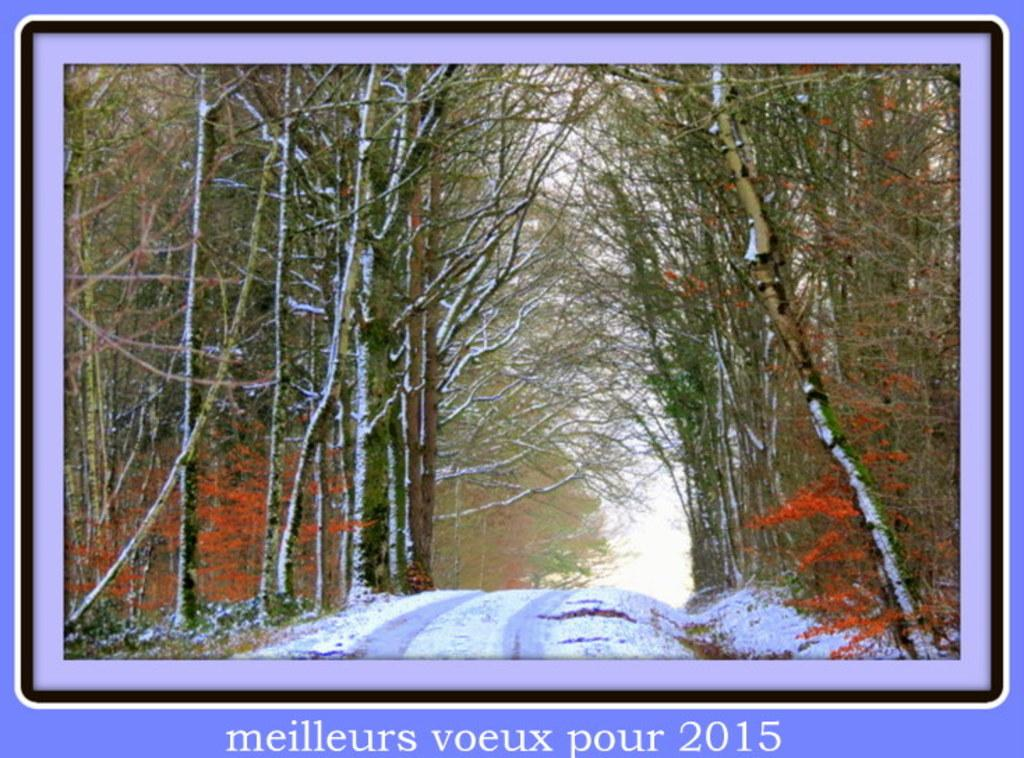What is the main feature of the image? There is a road in the image. How is the road affected by the weather? The road is filled with snow. What can be seen beside the road? There are trees beside the road. Can you see any goldfish swimming in the snow on the road? There are no goldfish present in the image; it features a snow-covered road with trees beside it. 